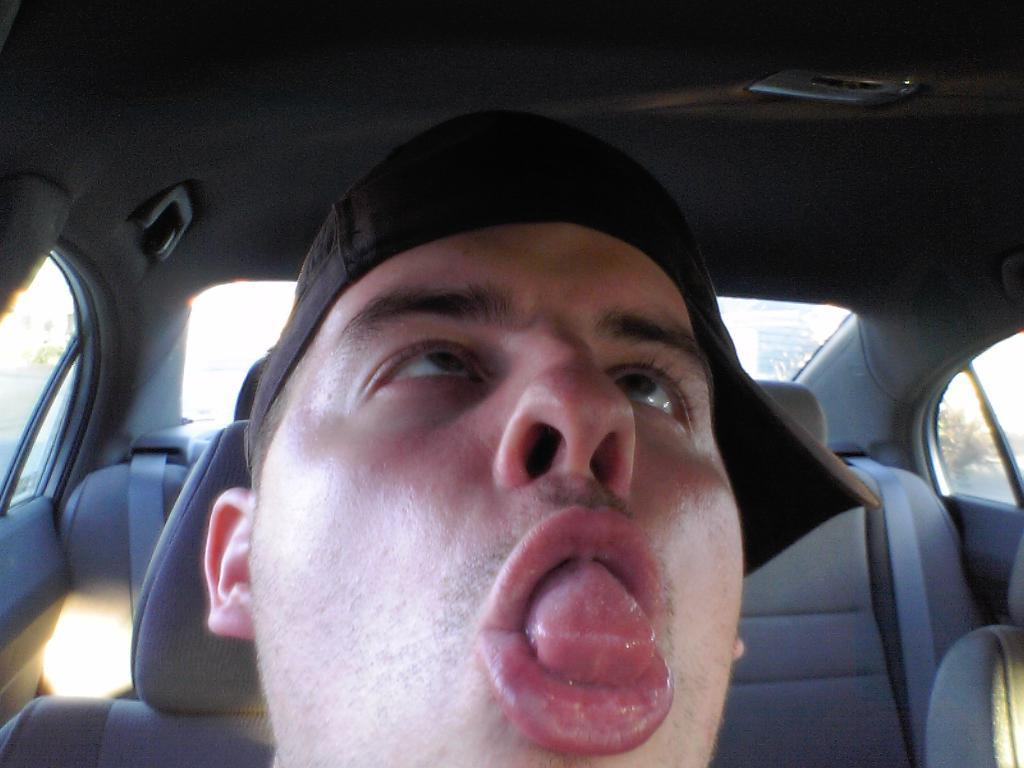Where was the image taken? The image is taken inside a car. Can you describe the person in the image? There is a person in the image, and they are wearing a cap. What type of government is being discussed in the image? There is no discussion of government in the image; it is focused on a person inside a car. Can you tell me how many dogs are present in the image? There are no dogs present in the image. 